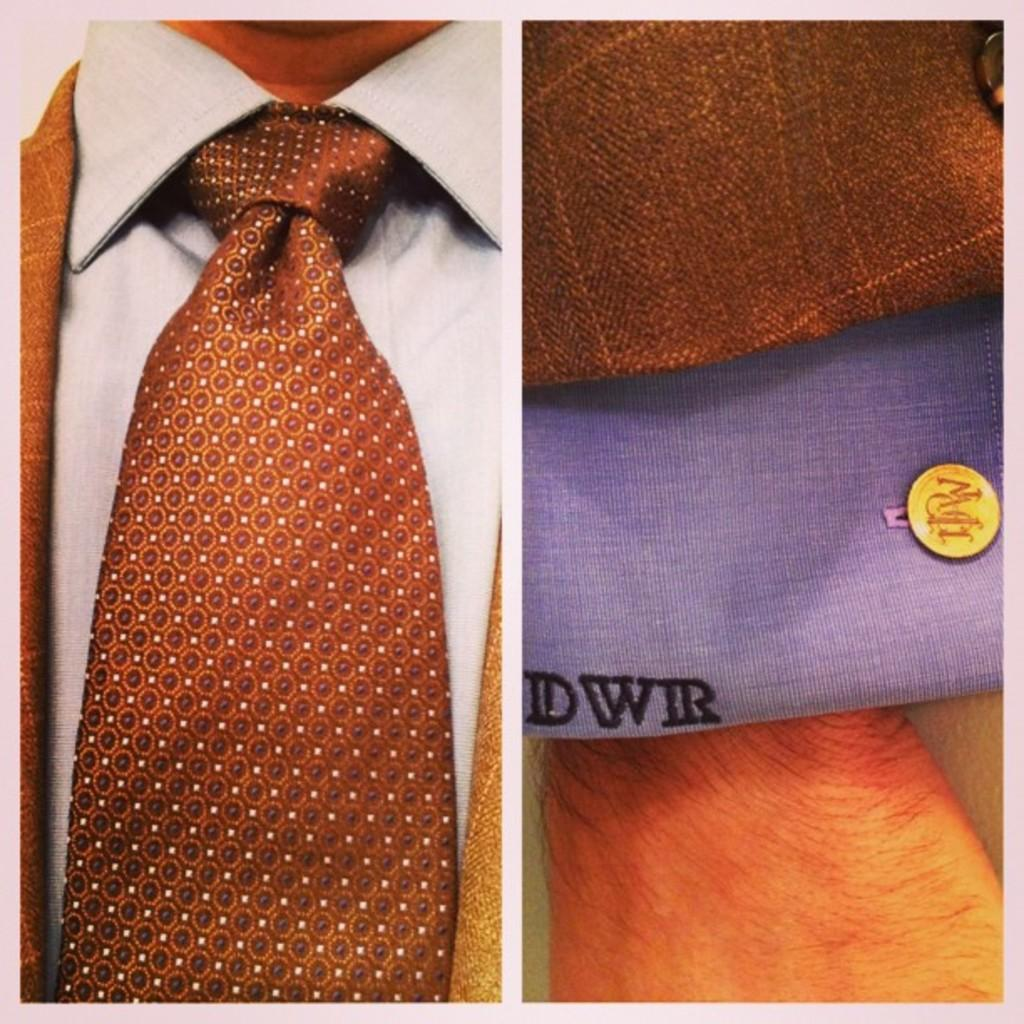What is the main feature of the image? The image contains a collage of two photos. Can you describe the person in the image? There is a person in the image, and they are wearing a blazer, shirt, and tie. Is there any text visible on the person's clothing? Yes, there is text visible on the person's clothing. What type of wren is perched on the person's shoulder in the image? There is no wren present in the image; it features a collage of two photos with a person wearing a blazer, shirt, and tie. 